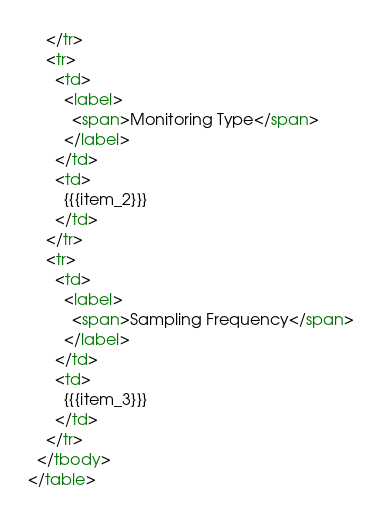<code> <loc_0><loc_0><loc_500><loc_500><_HTML_>    </tr>
    <tr>
      <td>
        <label>
          <span>Monitoring Type</span>
        </label>
      </td>
      <td>
        {{{item_2}}}
      </td>
    </tr>
    <tr>
      <td>
        <label>
          <span>Sampling Frequency</span>
        </label>
      </td>
      <td>
        {{{item_3}}}
      </td>
    </tr>
  </tbody>
</table></code> 